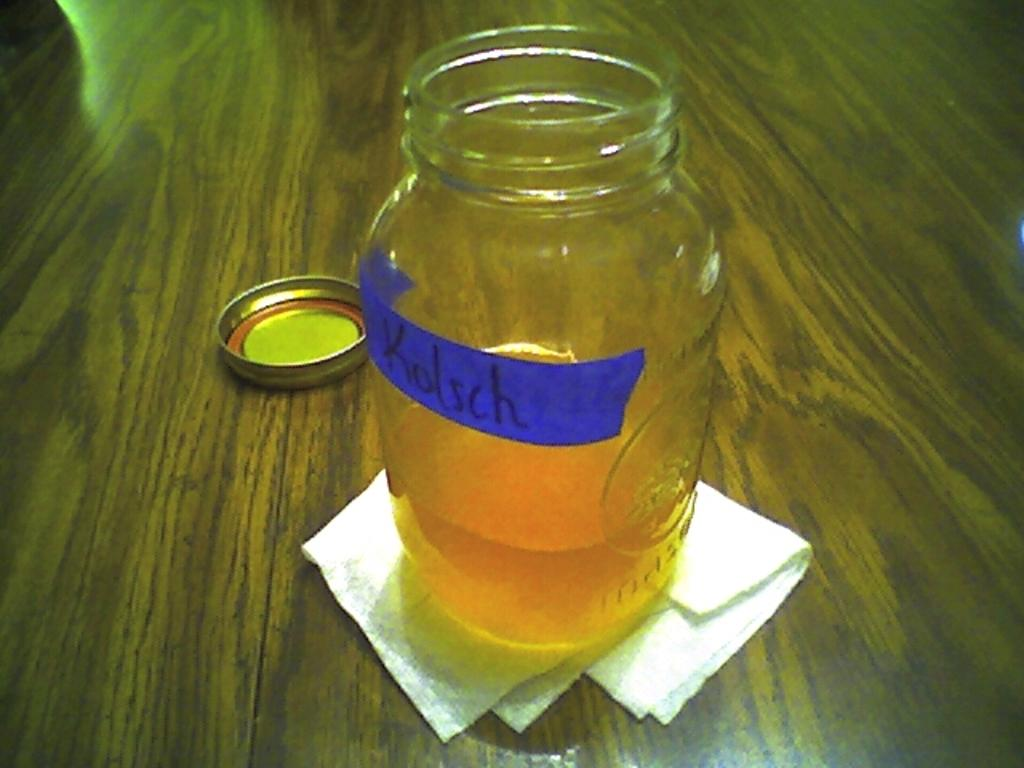Provide a one-sentence caption for the provided image. the name Kolsch is on the clear jar of liquid. 